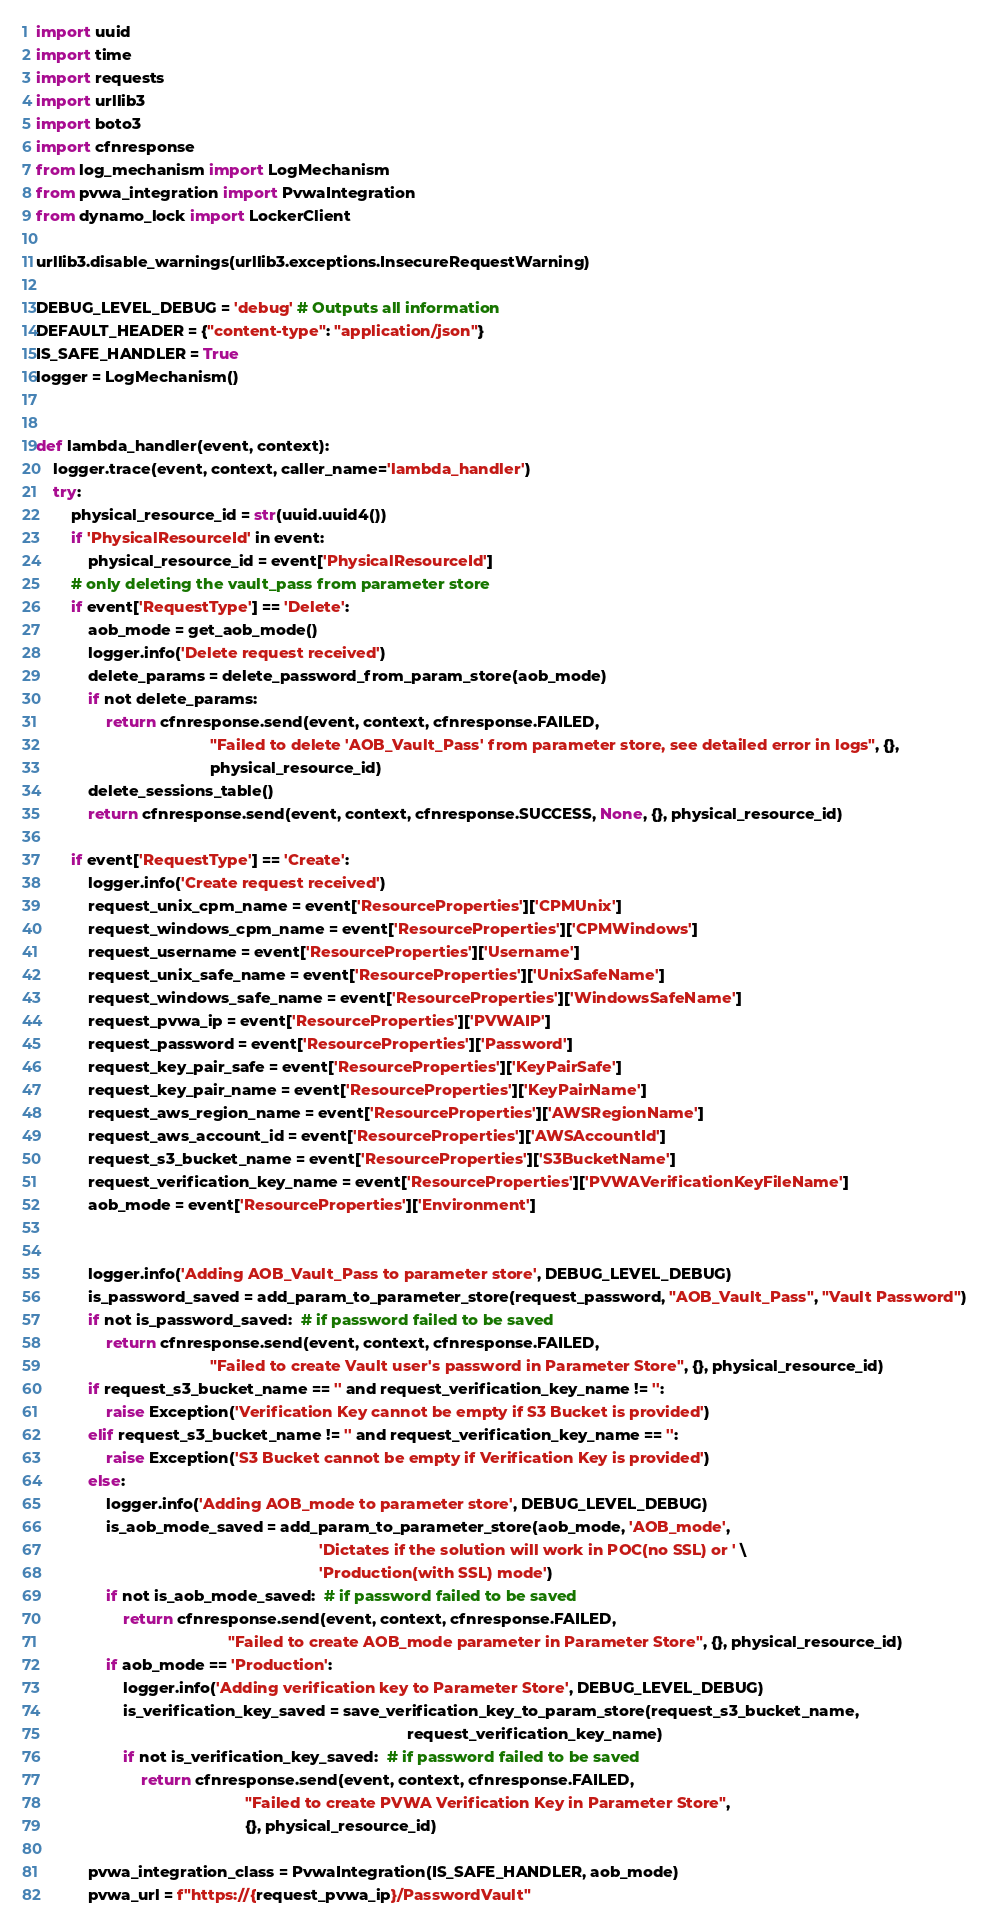<code> <loc_0><loc_0><loc_500><loc_500><_Python_>import uuid
import time
import requests
import urllib3
import boto3
import cfnresponse
from log_mechanism import LogMechanism
from pvwa_integration import PvwaIntegration
from dynamo_lock import LockerClient

urllib3.disable_warnings(urllib3.exceptions.InsecureRequestWarning)

DEBUG_LEVEL_DEBUG = 'debug' # Outputs all information
DEFAULT_HEADER = {"content-type": "application/json"}
IS_SAFE_HANDLER = True
logger = LogMechanism()


def lambda_handler(event, context):
    logger.trace(event, context, caller_name='lambda_handler')
    try:
        physical_resource_id = str(uuid.uuid4())
        if 'PhysicalResourceId' in event:
            physical_resource_id = event['PhysicalResourceId']
        # only deleting the vault_pass from parameter store
        if event['RequestType'] == 'Delete':
            aob_mode = get_aob_mode()
            logger.info('Delete request received')
            delete_params = delete_password_from_param_store(aob_mode)
            if not delete_params:
                return cfnresponse.send(event, context, cfnresponse.FAILED,
                                        "Failed to delete 'AOB_Vault_Pass' from parameter store, see detailed error in logs", {},
                                        physical_resource_id)
            delete_sessions_table()
            return cfnresponse.send(event, context, cfnresponse.SUCCESS, None, {}, physical_resource_id)

        if event['RequestType'] == 'Create':
            logger.info('Create request received')
            request_unix_cpm_name = event['ResourceProperties']['CPMUnix']
            request_windows_cpm_name = event['ResourceProperties']['CPMWindows']
            request_username = event['ResourceProperties']['Username']
            request_unix_safe_name = event['ResourceProperties']['UnixSafeName']
            request_windows_safe_name = event['ResourceProperties']['WindowsSafeName']
            request_pvwa_ip = event['ResourceProperties']['PVWAIP']
            request_password = event['ResourceProperties']['Password']
            request_key_pair_safe = event['ResourceProperties']['KeyPairSafe']
            request_key_pair_name = event['ResourceProperties']['KeyPairName']
            request_aws_region_name = event['ResourceProperties']['AWSRegionName']
            request_aws_account_id = event['ResourceProperties']['AWSAccountId']
            request_s3_bucket_name = event['ResourceProperties']['S3BucketName']
            request_verification_key_name = event['ResourceProperties']['PVWAVerificationKeyFileName']
            aob_mode = event['ResourceProperties']['Environment']


            logger.info('Adding AOB_Vault_Pass to parameter store', DEBUG_LEVEL_DEBUG)
            is_password_saved = add_param_to_parameter_store(request_password, "AOB_Vault_Pass", "Vault Password")
            if not is_password_saved:  # if password failed to be saved
                return cfnresponse.send(event, context, cfnresponse.FAILED,
                                        "Failed to create Vault user's password in Parameter Store", {}, physical_resource_id)
            if request_s3_bucket_name == '' and request_verification_key_name != '':
                raise Exception('Verification Key cannot be empty if S3 Bucket is provided')
            elif request_s3_bucket_name != '' and request_verification_key_name == '':
                raise Exception('S3 Bucket cannot be empty if Verification Key is provided')
            else:
                logger.info('Adding AOB_mode to parameter store', DEBUG_LEVEL_DEBUG)
                is_aob_mode_saved = add_param_to_parameter_store(aob_mode, 'AOB_mode',
                                                                 'Dictates if the solution will work in POC(no SSL) or ' \
                                                                 'Production(with SSL) mode')
                if not is_aob_mode_saved:  # if password failed to be saved
                    return cfnresponse.send(event, context, cfnresponse.FAILED,
                                            "Failed to create AOB_mode parameter in Parameter Store", {}, physical_resource_id)
                if aob_mode == 'Production':
                    logger.info('Adding verification key to Parameter Store', DEBUG_LEVEL_DEBUG)
                    is_verification_key_saved = save_verification_key_to_param_store(request_s3_bucket_name,
                                                                                     request_verification_key_name)
                    if not is_verification_key_saved:  # if password failed to be saved
                        return cfnresponse.send(event, context, cfnresponse.FAILED,
                                                "Failed to create PVWA Verification Key in Parameter Store",
                                                {}, physical_resource_id)

            pvwa_integration_class = PvwaIntegration(IS_SAFE_HANDLER, aob_mode)
            pvwa_url = f"https://{request_pvwa_ip}/PasswordVault"</code> 